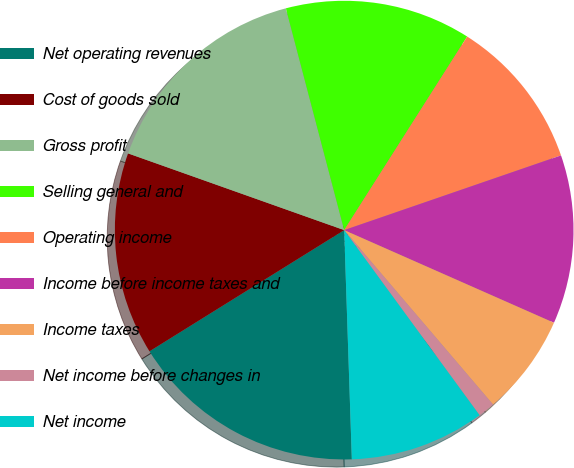Convert chart. <chart><loc_0><loc_0><loc_500><loc_500><pie_chart><fcel>Net operating revenues<fcel>Cost of goods sold<fcel>Gross profit<fcel>Selling general and<fcel>Operating income<fcel>Income before income taxes and<fcel>Income taxes<fcel>Net income before changes in<fcel>Net income<nl><fcel>16.67%<fcel>14.29%<fcel>15.48%<fcel>13.1%<fcel>10.71%<fcel>11.9%<fcel>7.14%<fcel>1.19%<fcel>9.52%<nl></chart> 